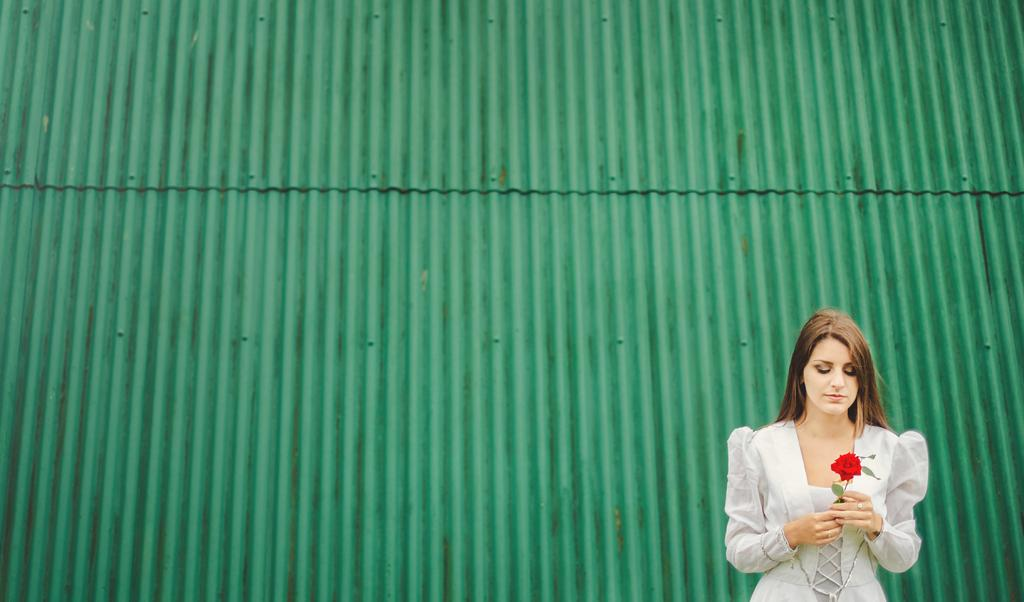What is the main subject of the image? The main subject of the image is a girl. What is the girl doing in the image? The girl is standing in the image. What is the girl holding in the image? The girl is holding a flower in her hand. What color is the flower? The flower is red in color. What is the color of the background in the image? The background of the image is red in color. What type of food is being prepared on the channel in the image? There is no channel or food preparation visible in the image. The image features a girl standing with a red flower in her hand against a red background. 